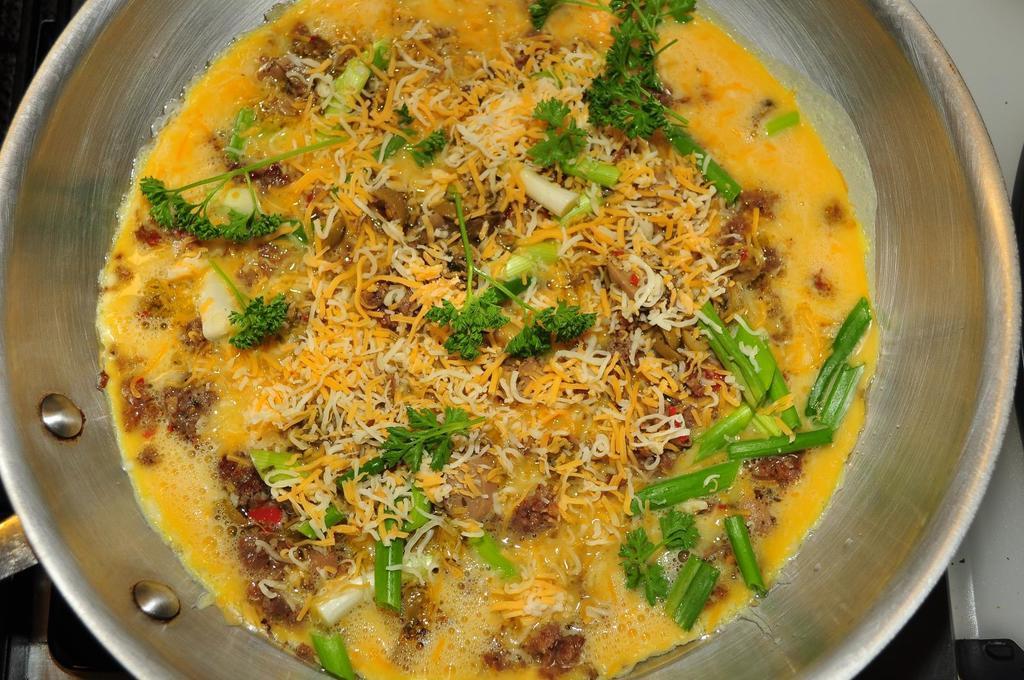In one or two sentences, can you explain what this image depicts? The picture consists of a food item in a bowl. The background is not clear. 